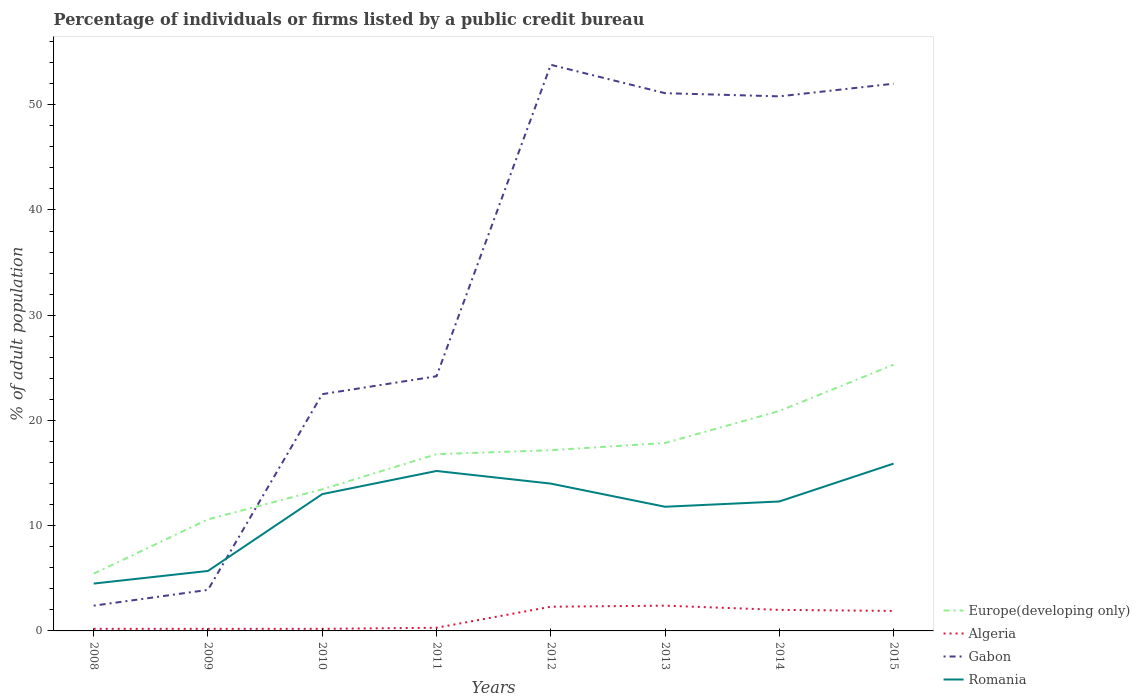How many different coloured lines are there?
Provide a short and direct response. 4. Does the line corresponding to Romania intersect with the line corresponding to Algeria?
Your answer should be compact. No. Across all years, what is the maximum percentage of population listed by a public credit bureau in Algeria?
Offer a terse response. 0.2. In which year was the percentage of population listed by a public credit bureau in Gabon maximum?
Offer a terse response. 2008. What is the total percentage of population listed by a public credit bureau in Europe(developing only) in the graph?
Your response must be concise. -8.51. What is the difference between the highest and the second highest percentage of population listed by a public credit bureau in Europe(developing only)?
Offer a very short reply. 19.86. What is the difference between the highest and the lowest percentage of population listed by a public credit bureau in Europe(developing only)?
Your response must be concise. 5. Is the percentage of population listed by a public credit bureau in Algeria strictly greater than the percentage of population listed by a public credit bureau in Gabon over the years?
Make the answer very short. Yes. Are the values on the major ticks of Y-axis written in scientific E-notation?
Offer a terse response. No. Does the graph contain any zero values?
Make the answer very short. No. Does the graph contain grids?
Your response must be concise. No. How many legend labels are there?
Ensure brevity in your answer.  4. What is the title of the graph?
Your answer should be compact. Percentage of individuals or firms listed by a public credit bureau. Does "United Arab Emirates" appear as one of the legend labels in the graph?
Your response must be concise. No. What is the label or title of the Y-axis?
Your answer should be very brief. % of adult population. What is the % of adult population of Europe(developing only) in 2008?
Your response must be concise. 5.44. What is the % of adult population of Algeria in 2008?
Provide a short and direct response. 0.2. What is the % of adult population in Gabon in 2008?
Make the answer very short. 2.4. What is the % of adult population of Europe(developing only) in 2009?
Ensure brevity in your answer.  10.6. What is the % of adult population in Algeria in 2009?
Keep it short and to the point. 0.2. What is the % of adult population of Gabon in 2009?
Keep it short and to the point. 3.9. What is the % of adult population in Romania in 2009?
Make the answer very short. 5.7. What is the % of adult population in Europe(developing only) in 2010?
Offer a terse response. 13.46. What is the % of adult population of Algeria in 2010?
Offer a very short reply. 0.2. What is the % of adult population of Romania in 2010?
Make the answer very short. 13. What is the % of adult population of Europe(developing only) in 2011?
Provide a short and direct response. 16.79. What is the % of adult population of Gabon in 2011?
Make the answer very short. 24.2. What is the % of adult population in Romania in 2011?
Ensure brevity in your answer.  15.2. What is the % of adult population of Europe(developing only) in 2012?
Offer a terse response. 17.17. What is the % of adult population in Gabon in 2012?
Provide a short and direct response. 53.8. What is the % of adult population in Europe(developing only) in 2013?
Offer a very short reply. 17.86. What is the % of adult population in Algeria in 2013?
Ensure brevity in your answer.  2.4. What is the % of adult population in Gabon in 2013?
Offer a terse response. 51.1. What is the % of adult population of Europe(developing only) in 2014?
Your response must be concise. 20.9. What is the % of adult population in Gabon in 2014?
Keep it short and to the point. 50.8. What is the % of adult population in Romania in 2014?
Give a very brief answer. 12.3. What is the % of adult population of Europe(developing only) in 2015?
Give a very brief answer. 25.3. What is the % of adult population of Gabon in 2015?
Make the answer very short. 52. Across all years, what is the maximum % of adult population of Europe(developing only)?
Provide a short and direct response. 25.3. Across all years, what is the maximum % of adult population of Gabon?
Your answer should be compact. 53.8. Across all years, what is the maximum % of adult population in Romania?
Keep it short and to the point. 15.9. Across all years, what is the minimum % of adult population of Europe(developing only)?
Make the answer very short. 5.44. Across all years, what is the minimum % of adult population in Algeria?
Make the answer very short. 0.2. Across all years, what is the minimum % of adult population of Romania?
Offer a terse response. 4.5. What is the total % of adult population in Europe(developing only) in the graph?
Provide a succinct answer. 127.52. What is the total % of adult population in Gabon in the graph?
Provide a succinct answer. 260.7. What is the total % of adult population in Romania in the graph?
Your answer should be compact. 92.4. What is the difference between the % of adult population of Europe(developing only) in 2008 and that in 2009?
Provide a succinct answer. -5.16. What is the difference between the % of adult population in Gabon in 2008 and that in 2009?
Your response must be concise. -1.5. What is the difference between the % of adult population of Romania in 2008 and that in 2009?
Provide a short and direct response. -1.2. What is the difference between the % of adult population in Europe(developing only) in 2008 and that in 2010?
Provide a succinct answer. -8.02. What is the difference between the % of adult population in Gabon in 2008 and that in 2010?
Offer a terse response. -20.1. What is the difference between the % of adult population of Romania in 2008 and that in 2010?
Provide a succinct answer. -8.5. What is the difference between the % of adult population in Europe(developing only) in 2008 and that in 2011?
Your response must be concise. -11.36. What is the difference between the % of adult population in Gabon in 2008 and that in 2011?
Offer a terse response. -21.8. What is the difference between the % of adult population in Europe(developing only) in 2008 and that in 2012?
Your answer should be compact. -11.73. What is the difference between the % of adult population in Gabon in 2008 and that in 2012?
Make the answer very short. -51.4. What is the difference between the % of adult population of Romania in 2008 and that in 2012?
Provide a succinct answer. -9.5. What is the difference between the % of adult population in Europe(developing only) in 2008 and that in 2013?
Provide a short and direct response. -12.42. What is the difference between the % of adult population in Gabon in 2008 and that in 2013?
Your response must be concise. -48.7. What is the difference between the % of adult population of Romania in 2008 and that in 2013?
Offer a terse response. -7.3. What is the difference between the % of adult population in Europe(developing only) in 2008 and that in 2014?
Offer a very short reply. -15.46. What is the difference between the % of adult population in Gabon in 2008 and that in 2014?
Your answer should be very brief. -48.4. What is the difference between the % of adult population in Europe(developing only) in 2008 and that in 2015?
Provide a succinct answer. -19.86. What is the difference between the % of adult population of Algeria in 2008 and that in 2015?
Your response must be concise. -1.7. What is the difference between the % of adult population of Gabon in 2008 and that in 2015?
Keep it short and to the point. -49.6. What is the difference between the % of adult population of Europe(developing only) in 2009 and that in 2010?
Provide a short and direct response. -2.86. What is the difference between the % of adult population in Gabon in 2009 and that in 2010?
Offer a very short reply. -18.6. What is the difference between the % of adult population in Romania in 2009 and that in 2010?
Provide a short and direct response. -7.3. What is the difference between the % of adult population in Europe(developing only) in 2009 and that in 2011?
Keep it short and to the point. -6.19. What is the difference between the % of adult population in Gabon in 2009 and that in 2011?
Offer a very short reply. -20.3. What is the difference between the % of adult population of Romania in 2009 and that in 2011?
Provide a succinct answer. -9.5. What is the difference between the % of adult population in Europe(developing only) in 2009 and that in 2012?
Your answer should be compact. -6.57. What is the difference between the % of adult population of Algeria in 2009 and that in 2012?
Offer a very short reply. -2.1. What is the difference between the % of adult population in Gabon in 2009 and that in 2012?
Your answer should be very brief. -49.9. What is the difference between the % of adult population of Romania in 2009 and that in 2012?
Keep it short and to the point. -8.3. What is the difference between the % of adult population in Europe(developing only) in 2009 and that in 2013?
Your response must be concise. -7.26. What is the difference between the % of adult population in Gabon in 2009 and that in 2013?
Offer a very short reply. -47.2. What is the difference between the % of adult population in Romania in 2009 and that in 2013?
Provide a short and direct response. -6.1. What is the difference between the % of adult population in Europe(developing only) in 2009 and that in 2014?
Keep it short and to the point. -10.3. What is the difference between the % of adult population of Gabon in 2009 and that in 2014?
Offer a very short reply. -46.9. What is the difference between the % of adult population in Europe(developing only) in 2009 and that in 2015?
Give a very brief answer. -14.7. What is the difference between the % of adult population of Gabon in 2009 and that in 2015?
Provide a short and direct response. -48.1. What is the difference between the % of adult population in Europe(developing only) in 2010 and that in 2011?
Your answer should be compact. -3.34. What is the difference between the % of adult population in Algeria in 2010 and that in 2011?
Provide a succinct answer. -0.1. What is the difference between the % of adult population of Gabon in 2010 and that in 2011?
Offer a very short reply. -1.7. What is the difference between the % of adult population in Romania in 2010 and that in 2011?
Make the answer very short. -2.2. What is the difference between the % of adult population of Europe(developing only) in 2010 and that in 2012?
Your response must be concise. -3.72. What is the difference between the % of adult population of Algeria in 2010 and that in 2012?
Your answer should be compact. -2.1. What is the difference between the % of adult population of Gabon in 2010 and that in 2012?
Your response must be concise. -31.3. What is the difference between the % of adult population of Europe(developing only) in 2010 and that in 2013?
Your answer should be very brief. -4.4. What is the difference between the % of adult population of Algeria in 2010 and that in 2013?
Provide a succinct answer. -2.2. What is the difference between the % of adult population in Gabon in 2010 and that in 2013?
Your answer should be compact. -28.6. What is the difference between the % of adult population of Europe(developing only) in 2010 and that in 2014?
Provide a succinct answer. -7.44. What is the difference between the % of adult population of Gabon in 2010 and that in 2014?
Offer a very short reply. -28.3. What is the difference between the % of adult population in Europe(developing only) in 2010 and that in 2015?
Offer a terse response. -11.84. What is the difference between the % of adult population in Gabon in 2010 and that in 2015?
Your answer should be compact. -29.5. What is the difference between the % of adult population in Europe(developing only) in 2011 and that in 2012?
Offer a terse response. -0.38. What is the difference between the % of adult population in Algeria in 2011 and that in 2012?
Keep it short and to the point. -2. What is the difference between the % of adult population of Gabon in 2011 and that in 2012?
Ensure brevity in your answer.  -29.6. What is the difference between the % of adult population of Europe(developing only) in 2011 and that in 2013?
Give a very brief answer. -1.06. What is the difference between the % of adult population of Algeria in 2011 and that in 2013?
Offer a very short reply. -2.1. What is the difference between the % of adult population in Gabon in 2011 and that in 2013?
Your answer should be very brief. -26.9. What is the difference between the % of adult population of Romania in 2011 and that in 2013?
Your answer should be very brief. 3.4. What is the difference between the % of adult population of Europe(developing only) in 2011 and that in 2014?
Your response must be concise. -4.11. What is the difference between the % of adult population in Gabon in 2011 and that in 2014?
Provide a succinct answer. -26.6. What is the difference between the % of adult population of Europe(developing only) in 2011 and that in 2015?
Make the answer very short. -8.51. What is the difference between the % of adult population in Algeria in 2011 and that in 2015?
Keep it short and to the point. -1.6. What is the difference between the % of adult population in Gabon in 2011 and that in 2015?
Your answer should be very brief. -27.8. What is the difference between the % of adult population in Europe(developing only) in 2012 and that in 2013?
Provide a succinct answer. -0.68. What is the difference between the % of adult population of Gabon in 2012 and that in 2013?
Offer a terse response. 2.7. What is the difference between the % of adult population in Romania in 2012 and that in 2013?
Offer a very short reply. 2.2. What is the difference between the % of adult population in Europe(developing only) in 2012 and that in 2014?
Offer a very short reply. -3.73. What is the difference between the % of adult population in Algeria in 2012 and that in 2014?
Keep it short and to the point. 0.3. What is the difference between the % of adult population in Romania in 2012 and that in 2014?
Provide a short and direct response. 1.7. What is the difference between the % of adult population of Europe(developing only) in 2012 and that in 2015?
Provide a succinct answer. -8.13. What is the difference between the % of adult population of Europe(developing only) in 2013 and that in 2014?
Provide a succinct answer. -3.04. What is the difference between the % of adult population of Gabon in 2013 and that in 2014?
Ensure brevity in your answer.  0.3. What is the difference between the % of adult population in Romania in 2013 and that in 2014?
Provide a short and direct response. -0.5. What is the difference between the % of adult population in Europe(developing only) in 2013 and that in 2015?
Make the answer very short. -7.44. What is the difference between the % of adult population of Algeria in 2013 and that in 2015?
Your answer should be compact. 0.5. What is the difference between the % of adult population of Romania in 2013 and that in 2015?
Your answer should be very brief. -4.1. What is the difference between the % of adult population of Europe(developing only) in 2014 and that in 2015?
Your response must be concise. -4.4. What is the difference between the % of adult population of Algeria in 2014 and that in 2015?
Ensure brevity in your answer.  0.1. What is the difference between the % of adult population in Europe(developing only) in 2008 and the % of adult population in Algeria in 2009?
Provide a short and direct response. 5.24. What is the difference between the % of adult population of Europe(developing only) in 2008 and the % of adult population of Gabon in 2009?
Provide a short and direct response. 1.54. What is the difference between the % of adult population in Europe(developing only) in 2008 and the % of adult population in Romania in 2009?
Make the answer very short. -0.26. What is the difference between the % of adult population of Algeria in 2008 and the % of adult population of Romania in 2009?
Provide a short and direct response. -5.5. What is the difference between the % of adult population in Gabon in 2008 and the % of adult population in Romania in 2009?
Provide a short and direct response. -3.3. What is the difference between the % of adult population in Europe(developing only) in 2008 and the % of adult population in Algeria in 2010?
Your answer should be very brief. 5.24. What is the difference between the % of adult population of Europe(developing only) in 2008 and the % of adult population of Gabon in 2010?
Ensure brevity in your answer.  -17.06. What is the difference between the % of adult population in Europe(developing only) in 2008 and the % of adult population in Romania in 2010?
Offer a very short reply. -7.56. What is the difference between the % of adult population of Algeria in 2008 and the % of adult population of Gabon in 2010?
Provide a succinct answer. -22.3. What is the difference between the % of adult population in Gabon in 2008 and the % of adult population in Romania in 2010?
Offer a terse response. -10.6. What is the difference between the % of adult population in Europe(developing only) in 2008 and the % of adult population in Algeria in 2011?
Give a very brief answer. 5.14. What is the difference between the % of adult population in Europe(developing only) in 2008 and the % of adult population in Gabon in 2011?
Offer a terse response. -18.76. What is the difference between the % of adult population of Europe(developing only) in 2008 and the % of adult population of Romania in 2011?
Offer a very short reply. -9.76. What is the difference between the % of adult population of Europe(developing only) in 2008 and the % of adult population of Algeria in 2012?
Ensure brevity in your answer.  3.14. What is the difference between the % of adult population in Europe(developing only) in 2008 and the % of adult population in Gabon in 2012?
Ensure brevity in your answer.  -48.36. What is the difference between the % of adult population in Europe(developing only) in 2008 and the % of adult population in Romania in 2012?
Provide a short and direct response. -8.56. What is the difference between the % of adult population of Algeria in 2008 and the % of adult population of Gabon in 2012?
Make the answer very short. -53.6. What is the difference between the % of adult population in Europe(developing only) in 2008 and the % of adult population in Algeria in 2013?
Ensure brevity in your answer.  3.04. What is the difference between the % of adult population in Europe(developing only) in 2008 and the % of adult population in Gabon in 2013?
Provide a short and direct response. -45.66. What is the difference between the % of adult population in Europe(developing only) in 2008 and the % of adult population in Romania in 2013?
Provide a short and direct response. -6.36. What is the difference between the % of adult population in Algeria in 2008 and the % of adult population in Gabon in 2013?
Ensure brevity in your answer.  -50.9. What is the difference between the % of adult population in Gabon in 2008 and the % of adult population in Romania in 2013?
Your answer should be very brief. -9.4. What is the difference between the % of adult population in Europe(developing only) in 2008 and the % of adult population in Algeria in 2014?
Give a very brief answer. 3.44. What is the difference between the % of adult population in Europe(developing only) in 2008 and the % of adult population in Gabon in 2014?
Keep it short and to the point. -45.36. What is the difference between the % of adult population in Europe(developing only) in 2008 and the % of adult population in Romania in 2014?
Your answer should be very brief. -6.86. What is the difference between the % of adult population of Algeria in 2008 and the % of adult population of Gabon in 2014?
Make the answer very short. -50.6. What is the difference between the % of adult population in Algeria in 2008 and the % of adult population in Romania in 2014?
Your response must be concise. -12.1. What is the difference between the % of adult population in Gabon in 2008 and the % of adult population in Romania in 2014?
Offer a terse response. -9.9. What is the difference between the % of adult population in Europe(developing only) in 2008 and the % of adult population in Algeria in 2015?
Make the answer very short. 3.54. What is the difference between the % of adult population of Europe(developing only) in 2008 and the % of adult population of Gabon in 2015?
Keep it short and to the point. -46.56. What is the difference between the % of adult population in Europe(developing only) in 2008 and the % of adult population in Romania in 2015?
Provide a succinct answer. -10.46. What is the difference between the % of adult population in Algeria in 2008 and the % of adult population in Gabon in 2015?
Offer a terse response. -51.8. What is the difference between the % of adult population of Algeria in 2008 and the % of adult population of Romania in 2015?
Give a very brief answer. -15.7. What is the difference between the % of adult population in Europe(developing only) in 2009 and the % of adult population in Gabon in 2010?
Your response must be concise. -11.9. What is the difference between the % of adult population of Algeria in 2009 and the % of adult population of Gabon in 2010?
Ensure brevity in your answer.  -22.3. What is the difference between the % of adult population of Gabon in 2009 and the % of adult population of Romania in 2010?
Keep it short and to the point. -9.1. What is the difference between the % of adult population of Algeria in 2009 and the % of adult population of Romania in 2011?
Ensure brevity in your answer.  -15. What is the difference between the % of adult population in Gabon in 2009 and the % of adult population in Romania in 2011?
Your answer should be very brief. -11.3. What is the difference between the % of adult population of Europe(developing only) in 2009 and the % of adult population of Gabon in 2012?
Make the answer very short. -43.2. What is the difference between the % of adult population of Algeria in 2009 and the % of adult population of Gabon in 2012?
Provide a succinct answer. -53.6. What is the difference between the % of adult population in Algeria in 2009 and the % of adult population in Romania in 2012?
Keep it short and to the point. -13.8. What is the difference between the % of adult population in Gabon in 2009 and the % of adult population in Romania in 2012?
Ensure brevity in your answer.  -10.1. What is the difference between the % of adult population in Europe(developing only) in 2009 and the % of adult population in Algeria in 2013?
Your answer should be compact. 8.2. What is the difference between the % of adult population in Europe(developing only) in 2009 and the % of adult population in Gabon in 2013?
Give a very brief answer. -40.5. What is the difference between the % of adult population in Europe(developing only) in 2009 and the % of adult population in Romania in 2013?
Offer a very short reply. -1.2. What is the difference between the % of adult population of Algeria in 2009 and the % of adult population of Gabon in 2013?
Give a very brief answer. -50.9. What is the difference between the % of adult population of Gabon in 2009 and the % of adult population of Romania in 2013?
Your response must be concise. -7.9. What is the difference between the % of adult population in Europe(developing only) in 2009 and the % of adult population in Gabon in 2014?
Your answer should be compact. -40.2. What is the difference between the % of adult population in Europe(developing only) in 2009 and the % of adult population in Romania in 2014?
Make the answer very short. -1.7. What is the difference between the % of adult population in Algeria in 2009 and the % of adult population in Gabon in 2014?
Your answer should be very brief. -50.6. What is the difference between the % of adult population in Algeria in 2009 and the % of adult population in Romania in 2014?
Your response must be concise. -12.1. What is the difference between the % of adult population in Gabon in 2009 and the % of adult population in Romania in 2014?
Provide a short and direct response. -8.4. What is the difference between the % of adult population in Europe(developing only) in 2009 and the % of adult population in Gabon in 2015?
Your answer should be compact. -41.4. What is the difference between the % of adult population in Algeria in 2009 and the % of adult population in Gabon in 2015?
Provide a short and direct response. -51.8. What is the difference between the % of adult population of Algeria in 2009 and the % of adult population of Romania in 2015?
Offer a terse response. -15.7. What is the difference between the % of adult population of Gabon in 2009 and the % of adult population of Romania in 2015?
Your answer should be compact. -12. What is the difference between the % of adult population in Europe(developing only) in 2010 and the % of adult population in Algeria in 2011?
Your response must be concise. 13.16. What is the difference between the % of adult population in Europe(developing only) in 2010 and the % of adult population in Gabon in 2011?
Keep it short and to the point. -10.74. What is the difference between the % of adult population of Europe(developing only) in 2010 and the % of adult population of Romania in 2011?
Provide a succinct answer. -1.74. What is the difference between the % of adult population in Algeria in 2010 and the % of adult population in Romania in 2011?
Offer a very short reply. -15. What is the difference between the % of adult population in Europe(developing only) in 2010 and the % of adult population in Algeria in 2012?
Give a very brief answer. 11.16. What is the difference between the % of adult population in Europe(developing only) in 2010 and the % of adult population in Gabon in 2012?
Ensure brevity in your answer.  -40.34. What is the difference between the % of adult population in Europe(developing only) in 2010 and the % of adult population in Romania in 2012?
Ensure brevity in your answer.  -0.54. What is the difference between the % of adult population in Algeria in 2010 and the % of adult population in Gabon in 2012?
Your answer should be very brief. -53.6. What is the difference between the % of adult population of Algeria in 2010 and the % of adult population of Romania in 2012?
Give a very brief answer. -13.8. What is the difference between the % of adult population of Gabon in 2010 and the % of adult population of Romania in 2012?
Make the answer very short. 8.5. What is the difference between the % of adult population of Europe(developing only) in 2010 and the % of adult population of Algeria in 2013?
Keep it short and to the point. 11.06. What is the difference between the % of adult population in Europe(developing only) in 2010 and the % of adult population in Gabon in 2013?
Give a very brief answer. -37.64. What is the difference between the % of adult population of Europe(developing only) in 2010 and the % of adult population of Romania in 2013?
Your answer should be compact. 1.66. What is the difference between the % of adult population in Algeria in 2010 and the % of adult population in Gabon in 2013?
Make the answer very short. -50.9. What is the difference between the % of adult population of Gabon in 2010 and the % of adult population of Romania in 2013?
Ensure brevity in your answer.  10.7. What is the difference between the % of adult population in Europe(developing only) in 2010 and the % of adult population in Algeria in 2014?
Make the answer very short. 11.46. What is the difference between the % of adult population of Europe(developing only) in 2010 and the % of adult population of Gabon in 2014?
Keep it short and to the point. -37.34. What is the difference between the % of adult population of Europe(developing only) in 2010 and the % of adult population of Romania in 2014?
Give a very brief answer. 1.16. What is the difference between the % of adult population in Algeria in 2010 and the % of adult population in Gabon in 2014?
Give a very brief answer. -50.6. What is the difference between the % of adult population in Gabon in 2010 and the % of adult population in Romania in 2014?
Ensure brevity in your answer.  10.2. What is the difference between the % of adult population of Europe(developing only) in 2010 and the % of adult population of Algeria in 2015?
Keep it short and to the point. 11.56. What is the difference between the % of adult population in Europe(developing only) in 2010 and the % of adult population in Gabon in 2015?
Your answer should be compact. -38.54. What is the difference between the % of adult population in Europe(developing only) in 2010 and the % of adult population in Romania in 2015?
Give a very brief answer. -2.44. What is the difference between the % of adult population of Algeria in 2010 and the % of adult population of Gabon in 2015?
Keep it short and to the point. -51.8. What is the difference between the % of adult population in Algeria in 2010 and the % of adult population in Romania in 2015?
Offer a terse response. -15.7. What is the difference between the % of adult population in Europe(developing only) in 2011 and the % of adult population in Algeria in 2012?
Your response must be concise. 14.49. What is the difference between the % of adult population of Europe(developing only) in 2011 and the % of adult population of Gabon in 2012?
Your answer should be very brief. -37.01. What is the difference between the % of adult population in Europe(developing only) in 2011 and the % of adult population in Romania in 2012?
Ensure brevity in your answer.  2.79. What is the difference between the % of adult population of Algeria in 2011 and the % of adult population of Gabon in 2012?
Keep it short and to the point. -53.5. What is the difference between the % of adult population of Algeria in 2011 and the % of adult population of Romania in 2012?
Your answer should be very brief. -13.7. What is the difference between the % of adult population in Gabon in 2011 and the % of adult population in Romania in 2012?
Give a very brief answer. 10.2. What is the difference between the % of adult population of Europe(developing only) in 2011 and the % of adult population of Algeria in 2013?
Your answer should be compact. 14.39. What is the difference between the % of adult population in Europe(developing only) in 2011 and the % of adult population in Gabon in 2013?
Give a very brief answer. -34.31. What is the difference between the % of adult population of Europe(developing only) in 2011 and the % of adult population of Romania in 2013?
Offer a terse response. 4.99. What is the difference between the % of adult population in Algeria in 2011 and the % of adult population in Gabon in 2013?
Ensure brevity in your answer.  -50.8. What is the difference between the % of adult population of Algeria in 2011 and the % of adult population of Romania in 2013?
Your answer should be very brief. -11.5. What is the difference between the % of adult population of Gabon in 2011 and the % of adult population of Romania in 2013?
Your response must be concise. 12.4. What is the difference between the % of adult population in Europe(developing only) in 2011 and the % of adult population in Algeria in 2014?
Ensure brevity in your answer.  14.79. What is the difference between the % of adult population of Europe(developing only) in 2011 and the % of adult population of Gabon in 2014?
Ensure brevity in your answer.  -34.01. What is the difference between the % of adult population of Europe(developing only) in 2011 and the % of adult population of Romania in 2014?
Keep it short and to the point. 4.49. What is the difference between the % of adult population of Algeria in 2011 and the % of adult population of Gabon in 2014?
Keep it short and to the point. -50.5. What is the difference between the % of adult population of Gabon in 2011 and the % of adult population of Romania in 2014?
Offer a terse response. 11.9. What is the difference between the % of adult population of Europe(developing only) in 2011 and the % of adult population of Algeria in 2015?
Offer a terse response. 14.89. What is the difference between the % of adult population in Europe(developing only) in 2011 and the % of adult population in Gabon in 2015?
Your response must be concise. -35.21. What is the difference between the % of adult population of Europe(developing only) in 2011 and the % of adult population of Romania in 2015?
Provide a short and direct response. 0.89. What is the difference between the % of adult population of Algeria in 2011 and the % of adult population of Gabon in 2015?
Provide a short and direct response. -51.7. What is the difference between the % of adult population in Algeria in 2011 and the % of adult population in Romania in 2015?
Your answer should be compact. -15.6. What is the difference between the % of adult population in Gabon in 2011 and the % of adult population in Romania in 2015?
Offer a very short reply. 8.3. What is the difference between the % of adult population in Europe(developing only) in 2012 and the % of adult population in Algeria in 2013?
Provide a short and direct response. 14.77. What is the difference between the % of adult population of Europe(developing only) in 2012 and the % of adult population of Gabon in 2013?
Provide a short and direct response. -33.93. What is the difference between the % of adult population in Europe(developing only) in 2012 and the % of adult population in Romania in 2013?
Ensure brevity in your answer.  5.37. What is the difference between the % of adult population in Algeria in 2012 and the % of adult population in Gabon in 2013?
Ensure brevity in your answer.  -48.8. What is the difference between the % of adult population in Algeria in 2012 and the % of adult population in Romania in 2013?
Offer a terse response. -9.5. What is the difference between the % of adult population of Gabon in 2012 and the % of adult population of Romania in 2013?
Give a very brief answer. 42. What is the difference between the % of adult population in Europe(developing only) in 2012 and the % of adult population in Algeria in 2014?
Keep it short and to the point. 15.17. What is the difference between the % of adult population of Europe(developing only) in 2012 and the % of adult population of Gabon in 2014?
Keep it short and to the point. -33.63. What is the difference between the % of adult population of Europe(developing only) in 2012 and the % of adult population of Romania in 2014?
Offer a terse response. 4.87. What is the difference between the % of adult population in Algeria in 2012 and the % of adult population in Gabon in 2014?
Provide a succinct answer. -48.5. What is the difference between the % of adult population of Algeria in 2012 and the % of adult population of Romania in 2014?
Provide a short and direct response. -10. What is the difference between the % of adult population in Gabon in 2012 and the % of adult population in Romania in 2014?
Give a very brief answer. 41.5. What is the difference between the % of adult population of Europe(developing only) in 2012 and the % of adult population of Algeria in 2015?
Your answer should be compact. 15.27. What is the difference between the % of adult population in Europe(developing only) in 2012 and the % of adult population in Gabon in 2015?
Your answer should be very brief. -34.83. What is the difference between the % of adult population of Europe(developing only) in 2012 and the % of adult population of Romania in 2015?
Provide a short and direct response. 1.27. What is the difference between the % of adult population in Algeria in 2012 and the % of adult population in Gabon in 2015?
Offer a terse response. -49.7. What is the difference between the % of adult population in Gabon in 2012 and the % of adult population in Romania in 2015?
Ensure brevity in your answer.  37.9. What is the difference between the % of adult population of Europe(developing only) in 2013 and the % of adult population of Algeria in 2014?
Offer a very short reply. 15.86. What is the difference between the % of adult population of Europe(developing only) in 2013 and the % of adult population of Gabon in 2014?
Your answer should be very brief. -32.94. What is the difference between the % of adult population of Europe(developing only) in 2013 and the % of adult population of Romania in 2014?
Keep it short and to the point. 5.56. What is the difference between the % of adult population in Algeria in 2013 and the % of adult population in Gabon in 2014?
Provide a short and direct response. -48.4. What is the difference between the % of adult population of Algeria in 2013 and the % of adult population of Romania in 2014?
Provide a short and direct response. -9.9. What is the difference between the % of adult population in Gabon in 2013 and the % of adult population in Romania in 2014?
Ensure brevity in your answer.  38.8. What is the difference between the % of adult population in Europe(developing only) in 2013 and the % of adult population in Algeria in 2015?
Your answer should be compact. 15.96. What is the difference between the % of adult population of Europe(developing only) in 2013 and the % of adult population of Gabon in 2015?
Your answer should be compact. -34.14. What is the difference between the % of adult population of Europe(developing only) in 2013 and the % of adult population of Romania in 2015?
Your response must be concise. 1.96. What is the difference between the % of adult population of Algeria in 2013 and the % of adult population of Gabon in 2015?
Offer a very short reply. -49.6. What is the difference between the % of adult population of Gabon in 2013 and the % of adult population of Romania in 2015?
Keep it short and to the point. 35.2. What is the difference between the % of adult population of Europe(developing only) in 2014 and the % of adult population of Algeria in 2015?
Offer a very short reply. 19. What is the difference between the % of adult population of Europe(developing only) in 2014 and the % of adult population of Gabon in 2015?
Your answer should be very brief. -31.1. What is the difference between the % of adult population in Europe(developing only) in 2014 and the % of adult population in Romania in 2015?
Your answer should be very brief. 5. What is the difference between the % of adult population in Algeria in 2014 and the % of adult population in Gabon in 2015?
Keep it short and to the point. -50. What is the difference between the % of adult population of Gabon in 2014 and the % of adult population of Romania in 2015?
Offer a terse response. 34.9. What is the average % of adult population in Europe(developing only) per year?
Your answer should be very brief. 15.94. What is the average % of adult population of Algeria per year?
Your response must be concise. 1.19. What is the average % of adult population of Gabon per year?
Keep it short and to the point. 32.59. What is the average % of adult population in Romania per year?
Offer a terse response. 11.55. In the year 2008, what is the difference between the % of adult population of Europe(developing only) and % of adult population of Algeria?
Your response must be concise. 5.24. In the year 2008, what is the difference between the % of adult population in Europe(developing only) and % of adult population in Gabon?
Your answer should be very brief. 3.04. In the year 2008, what is the difference between the % of adult population of Europe(developing only) and % of adult population of Romania?
Your answer should be compact. 0.94. In the year 2009, what is the difference between the % of adult population of Europe(developing only) and % of adult population of Algeria?
Offer a terse response. 10.4. In the year 2009, what is the difference between the % of adult population in Europe(developing only) and % of adult population in Gabon?
Make the answer very short. 6.7. In the year 2009, what is the difference between the % of adult population of Europe(developing only) and % of adult population of Romania?
Ensure brevity in your answer.  4.9. In the year 2009, what is the difference between the % of adult population of Algeria and % of adult population of Romania?
Your answer should be compact. -5.5. In the year 2010, what is the difference between the % of adult population in Europe(developing only) and % of adult population in Algeria?
Offer a very short reply. 13.26. In the year 2010, what is the difference between the % of adult population in Europe(developing only) and % of adult population in Gabon?
Give a very brief answer. -9.04. In the year 2010, what is the difference between the % of adult population in Europe(developing only) and % of adult population in Romania?
Your response must be concise. 0.46. In the year 2010, what is the difference between the % of adult population in Algeria and % of adult population in Gabon?
Make the answer very short. -22.3. In the year 2010, what is the difference between the % of adult population in Algeria and % of adult population in Romania?
Make the answer very short. -12.8. In the year 2011, what is the difference between the % of adult population of Europe(developing only) and % of adult population of Algeria?
Your answer should be very brief. 16.49. In the year 2011, what is the difference between the % of adult population in Europe(developing only) and % of adult population in Gabon?
Make the answer very short. -7.41. In the year 2011, what is the difference between the % of adult population in Europe(developing only) and % of adult population in Romania?
Offer a very short reply. 1.59. In the year 2011, what is the difference between the % of adult population of Algeria and % of adult population of Gabon?
Give a very brief answer. -23.9. In the year 2011, what is the difference between the % of adult population of Algeria and % of adult population of Romania?
Keep it short and to the point. -14.9. In the year 2011, what is the difference between the % of adult population in Gabon and % of adult population in Romania?
Your answer should be very brief. 9. In the year 2012, what is the difference between the % of adult population in Europe(developing only) and % of adult population in Algeria?
Your answer should be very brief. 14.87. In the year 2012, what is the difference between the % of adult population in Europe(developing only) and % of adult population in Gabon?
Your answer should be very brief. -36.63. In the year 2012, what is the difference between the % of adult population in Europe(developing only) and % of adult population in Romania?
Make the answer very short. 3.17. In the year 2012, what is the difference between the % of adult population of Algeria and % of adult population of Gabon?
Your answer should be compact. -51.5. In the year 2012, what is the difference between the % of adult population of Algeria and % of adult population of Romania?
Your answer should be very brief. -11.7. In the year 2012, what is the difference between the % of adult population of Gabon and % of adult population of Romania?
Offer a terse response. 39.8. In the year 2013, what is the difference between the % of adult population of Europe(developing only) and % of adult population of Algeria?
Your answer should be very brief. 15.46. In the year 2013, what is the difference between the % of adult population in Europe(developing only) and % of adult population in Gabon?
Ensure brevity in your answer.  -33.24. In the year 2013, what is the difference between the % of adult population of Europe(developing only) and % of adult population of Romania?
Provide a succinct answer. 6.06. In the year 2013, what is the difference between the % of adult population of Algeria and % of adult population of Gabon?
Your response must be concise. -48.7. In the year 2013, what is the difference between the % of adult population of Algeria and % of adult population of Romania?
Keep it short and to the point. -9.4. In the year 2013, what is the difference between the % of adult population of Gabon and % of adult population of Romania?
Your response must be concise. 39.3. In the year 2014, what is the difference between the % of adult population in Europe(developing only) and % of adult population in Algeria?
Make the answer very short. 18.9. In the year 2014, what is the difference between the % of adult population in Europe(developing only) and % of adult population in Gabon?
Provide a short and direct response. -29.9. In the year 2014, what is the difference between the % of adult population of Algeria and % of adult population of Gabon?
Your response must be concise. -48.8. In the year 2014, what is the difference between the % of adult population of Algeria and % of adult population of Romania?
Offer a very short reply. -10.3. In the year 2014, what is the difference between the % of adult population in Gabon and % of adult population in Romania?
Keep it short and to the point. 38.5. In the year 2015, what is the difference between the % of adult population of Europe(developing only) and % of adult population of Algeria?
Provide a succinct answer. 23.4. In the year 2015, what is the difference between the % of adult population in Europe(developing only) and % of adult population in Gabon?
Offer a very short reply. -26.7. In the year 2015, what is the difference between the % of adult population in Europe(developing only) and % of adult population in Romania?
Your answer should be very brief. 9.4. In the year 2015, what is the difference between the % of adult population in Algeria and % of adult population in Gabon?
Ensure brevity in your answer.  -50.1. In the year 2015, what is the difference between the % of adult population of Algeria and % of adult population of Romania?
Make the answer very short. -14. In the year 2015, what is the difference between the % of adult population in Gabon and % of adult population in Romania?
Your answer should be very brief. 36.1. What is the ratio of the % of adult population in Europe(developing only) in 2008 to that in 2009?
Your response must be concise. 0.51. What is the ratio of the % of adult population in Algeria in 2008 to that in 2009?
Provide a succinct answer. 1. What is the ratio of the % of adult population in Gabon in 2008 to that in 2009?
Provide a short and direct response. 0.62. What is the ratio of the % of adult population of Romania in 2008 to that in 2009?
Your answer should be very brief. 0.79. What is the ratio of the % of adult population of Europe(developing only) in 2008 to that in 2010?
Give a very brief answer. 0.4. What is the ratio of the % of adult population of Gabon in 2008 to that in 2010?
Offer a terse response. 0.11. What is the ratio of the % of adult population in Romania in 2008 to that in 2010?
Ensure brevity in your answer.  0.35. What is the ratio of the % of adult population of Europe(developing only) in 2008 to that in 2011?
Make the answer very short. 0.32. What is the ratio of the % of adult population of Algeria in 2008 to that in 2011?
Give a very brief answer. 0.67. What is the ratio of the % of adult population in Gabon in 2008 to that in 2011?
Keep it short and to the point. 0.1. What is the ratio of the % of adult population of Romania in 2008 to that in 2011?
Give a very brief answer. 0.3. What is the ratio of the % of adult population of Europe(developing only) in 2008 to that in 2012?
Offer a terse response. 0.32. What is the ratio of the % of adult population of Algeria in 2008 to that in 2012?
Offer a very short reply. 0.09. What is the ratio of the % of adult population in Gabon in 2008 to that in 2012?
Ensure brevity in your answer.  0.04. What is the ratio of the % of adult population in Romania in 2008 to that in 2012?
Provide a succinct answer. 0.32. What is the ratio of the % of adult population of Europe(developing only) in 2008 to that in 2013?
Keep it short and to the point. 0.3. What is the ratio of the % of adult population of Algeria in 2008 to that in 2013?
Your response must be concise. 0.08. What is the ratio of the % of adult population in Gabon in 2008 to that in 2013?
Give a very brief answer. 0.05. What is the ratio of the % of adult population in Romania in 2008 to that in 2013?
Give a very brief answer. 0.38. What is the ratio of the % of adult population in Europe(developing only) in 2008 to that in 2014?
Ensure brevity in your answer.  0.26. What is the ratio of the % of adult population of Algeria in 2008 to that in 2014?
Give a very brief answer. 0.1. What is the ratio of the % of adult population in Gabon in 2008 to that in 2014?
Ensure brevity in your answer.  0.05. What is the ratio of the % of adult population of Romania in 2008 to that in 2014?
Offer a very short reply. 0.37. What is the ratio of the % of adult population in Europe(developing only) in 2008 to that in 2015?
Ensure brevity in your answer.  0.21. What is the ratio of the % of adult population of Algeria in 2008 to that in 2015?
Offer a very short reply. 0.11. What is the ratio of the % of adult population in Gabon in 2008 to that in 2015?
Ensure brevity in your answer.  0.05. What is the ratio of the % of adult population of Romania in 2008 to that in 2015?
Offer a terse response. 0.28. What is the ratio of the % of adult population in Europe(developing only) in 2009 to that in 2010?
Provide a succinct answer. 0.79. What is the ratio of the % of adult population in Gabon in 2009 to that in 2010?
Offer a terse response. 0.17. What is the ratio of the % of adult population in Romania in 2009 to that in 2010?
Provide a short and direct response. 0.44. What is the ratio of the % of adult population of Europe(developing only) in 2009 to that in 2011?
Your answer should be compact. 0.63. What is the ratio of the % of adult population in Algeria in 2009 to that in 2011?
Keep it short and to the point. 0.67. What is the ratio of the % of adult population of Gabon in 2009 to that in 2011?
Offer a terse response. 0.16. What is the ratio of the % of adult population in Europe(developing only) in 2009 to that in 2012?
Your answer should be very brief. 0.62. What is the ratio of the % of adult population in Algeria in 2009 to that in 2012?
Offer a terse response. 0.09. What is the ratio of the % of adult population of Gabon in 2009 to that in 2012?
Offer a terse response. 0.07. What is the ratio of the % of adult population of Romania in 2009 to that in 2012?
Your answer should be very brief. 0.41. What is the ratio of the % of adult population of Europe(developing only) in 2009 to that in 2013?
Your response must be concise. 0.59. What is the ratio of the % of adult population in Algeria in 2009 to that in 2013?
Offer a very short reply. 0.08. What is the ratio of the % of adult population in Gabon in 2009 to that in 2013?
Offer a terse response. 0.08. What is the ratio of the % of adult population in Romania in 2009 to that in 2013?
Make the answer very short. 0.48. What is the ratio of the % of adult population in Europe(developing only) in 2009 to that in 2014?
Keep it short and to the point. 0.51. What is the ratio of the % of adult population of Algeria in 2009 to that in 2014?
Your answer should be very brief. 0.1. What is the ratio of the % of adult population in Gabon in 2009 to that in 2014?
Give a very brief answer. 0.08. What is the ratio of the % of adult population of Romania in 2009 to that in 2014?
Your answer should be compact. 0.46. What is the ratio of the % of adult population in Europe(developing only) in 2009 to that in 2015?
Offer a very short reply. 0.42. What is the ratio of the % of adult population in Algeria in 2009 to that in 2015?
Offer a terse response. 0.11. What is the ratio of the % of adult population in Gabon in 2009 to that in 2015?
Ensure brevity in your answer.  0.07. What is the ratio of the % of adult population of Romania in 2009 to that in 2015?
Ensure brevity in your answer.  0.36. What is the ratio of the % of adult population of Europe(developing only) in 2010 to that in 2011?
Give a very brief answer. 0.8. What is the ratio of the % of adult population in Gabon in 2010 to that in 2011?
Make the answer very short. 0.93. What is the ratio of the % of adult population of Romania in 2010 to that in 2011?
Provide a succinct answer. 0.86. What is the ratio of the % of adult population of Europe(developing only) in 2010 to that in 2012?
Offer a terse response. 0.78. What is the ratio of the % of adult population of Algeria in 2010 to that in 2012?
Provide a short and direct response. 0.09. What is the ratio of the % of adult population of Gabon in 2010 to that in 2012?
Give a very brief answer. 0.42. What is the ratio of the % of adult population in Romania in 2010 to that in 2012?
Keep it short and to the point. 0.93. What is the ratio of the % of adult population of Europe(developing only) in 2010 to that in 2013?
Provide a short and direct response. 0.75. What is the ratio of the % of adult population of Algeria in 2010 to that in 2013?
Offer a very short reply. 0.08. What is the ratio of the % of adult population in Gabon in 2010 to that in 2013?
Your answer should be compact. 0.44. What is the ratio of the % of adult population of Romania in 2010 to that in 2013?
Ensure brevity in your answer.  1.1. What is the ratio of the % of adult population of Europe(developing only) in 2010 to that in 2014?
Offer a terse response. 0.64. What is the ratio of the % of adult population in Algeria in 2010 to that in 2014?
Keep it short and to the point. 0.1. What is the ratio of the % of adult population in Gabon in 2010 to that in 2014?
Give a very brief answer. 0.44. What is the ratio of the % of adult population in Romania in 2010 to that in 2014?
Your answer should be very brief. 1.06. What is the ratio of the % of adult population of Europe(developing only) in 2010 to that in 2015?
Offer a very short reply. 0.53. What is the ratio of the % of adult population of Algeria in 2010 to that in 2015?
Offer a very short reply. 0.11. What is the ratio of the % of adult population of Gabon in 2010 to that in 2015?
Give a very brief answer. 0.43. What is the ratio of the % of adult population of Romania in 2010 to that in 2015?
Ensure brevity in your answer.  0.82. What is the ratio of the % of adult population in Europe(developing only) in 2011 to that in 2012?
Your answer should be very brief. 0.98. What is the ratio of the % of adult population of Algeria in 2011 to that in 2012?
Make the answer very short. 0.13. What is the ratio of the % of adult population in Gabon in 2011 to that in 2012?
Offer a very short reply. 0.45. What is the ratio of the % of adult population in Romania in 2011 to that in 2012?
Keep it short and to the point. 1.09. What is the ratio of the % of adult population in Europe(developing only) in 2011 to that in 2013?
Ensure brevity in your answer.  0.94. What is the ratio of the % of adult population of Gabon in 2011 to that in 2013?
Offer a terse response. 0.47. What is the ratio of the % of adult population in Romania in 2011 to that in 2013?
Ensure brevity in your answer.  1.29. What is the ratio of the % of adult population in Europe(developing only) in 2011 to that in 2014?
Offer a terse response. 0.8. What is the ratio of the % of adult population in Gabon in 2011 to that in 2014?
Your response must be concise. 0.48. What is the ratio of the % of adult population in Romania in 2011 to that in 2014?
Ensure brevity in your answer.  1.24. What is the ratio of the % of adult population of Europe(developing only) in 2011 to that in 2015?
Give a very brief answer. 0.66. What is the ratio of the % of adult population of Algeria in 2011 to that in 2015?
Your answer should be very brief. 0.16. What is the ratio of the % of adult population in Gabon in 2011 to that in 2015?
Keep it short and to the point. 0.47. What is the ratio of the % of adult population of Romania in 2011 to that in 2015?
Provide a succinct answer. 0.96. What is the ratio of the % of adult population in Europe(developing only) in 2012 to that in 2013?
Offer a very short reply. 0.96. What is the ratio of the % of adult population of Gabon in 2012 to that in 2013?
Keep it short and to the point. 1.05. What is the ratio of the % of adult population of Romania in 2012 to that in 2013?
Your answer should be very brief. 1.19. What is the ratio of the % of adult population of Europe(developing only) in 2012 to that in 2014?
Offer a very short reply. 0.82. What is the ratio of the % of adult population in Algeria in 2012 to that in 2014?
Offer a terse response. 1.15. What is the ratio of the % of adult population in Gabon in 2012 to that in 2014?
Make the answer very short. 1.06. What is the ratio of the % of adult population in Romania in 2012 to that in 2014?
Offer a terse response. 1.14. What is the ratio of the % of adult population in Europe(developing only) in 2012 to that in 2015?
Your answer should be very brief. 0.68. What is the ratio of the % of adult population in Algeria in 2012 to that in 2015?
Give a very brief answer. 1.21. What is the ratio of the % of adult population in Gabon in 2012 to that in 2015?
Your answer should be very brief. 1.03. What is the ratio of the % of adult population of Romania in 2012 to that in 2015?
Ensure brevity in your answer.  0.88. What is the ratio of the % of adult population in Europe(developing only) in 2013 to that in 2014?
Your response must be concise. 0.85. What is the ratio of the % of adult population of Gabon in 2013 to that in 2014?
Your response must be concise. 1.01. What is the ratio of the % of adult population of Romania in 2013 to that in 2014?
Give a very brief answer. 0.96. What is the ratio of the % of adult population in Europe(developing only) in 2013 to that in 2015?
Offer a very short reply. 0.71. What is the ratio of the % of adult population in Algeria in 2013 to that in 2015?
Offer a terse response. 1.26. What is the ratio of the % of adult population of Gabon in 2013 to that in 2015?
Your answer should be very brief. 0.98. What is the ratio of the % of adult population of Romania in 2013 to that in 2015?
Your answer should be very brief. 0.74. What is the ratio of the % of adult population in Europe(developing only) in 2014 to that in 2015?
Make the answer very short. 0.83. What is the ratio of the % of adult population in Algeria in 2014 to that in 2015?
Provide a short and direct response. 1.05. What is the ratio of the % of adult population of Gabon in 2014 to that in 2015?
Your answer should be very brief. 0.98. What is the ratio of the % of adult population of Romania in 2014 to that in 2015?
Make the answer very short. 0.77. What is the difference between the highest and the second highest % of adult population in Romania?
Keep it short and to the point. 0.7. What is the difference between the highest and the lowest % of adult population in Europe(developing only)?
Make the answer very short. 19.86. What is the difference between the highest and the lowest % of adult population in Algeria?
Your answer should be compact. 2.2. What is the difference between the highest and the lowest % of adult population of Gabon?
Keep it short and to the point. 51.4. 